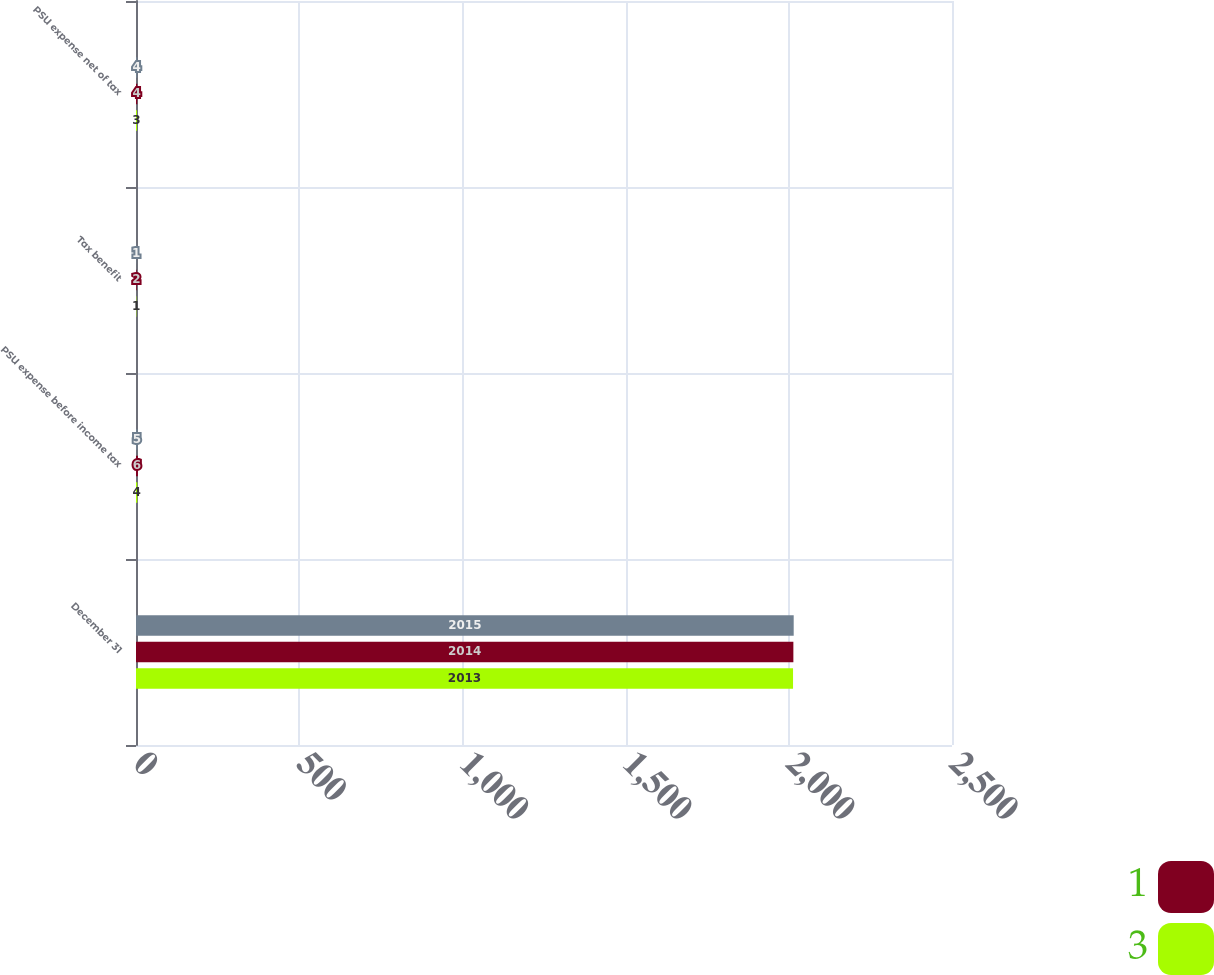<chart> <loc_0><loc_0><loc_500><loc_500><stacked_bar_chart><ecel><fcel>December 31<fcel>PSU expense before income tax<fcel>Tax benefit<fcel>PSU expense net of tax<nl><fcel>nan<fcel>2015<fcel>5<fcel>1<fcel>4<nl><fcel>1<fcel>2014<fcel>6<fcel>2<fcel>4<nl><fcel>3<fcel>2013<fcel>4<fcel>1<fcel>3<nl></chart> 